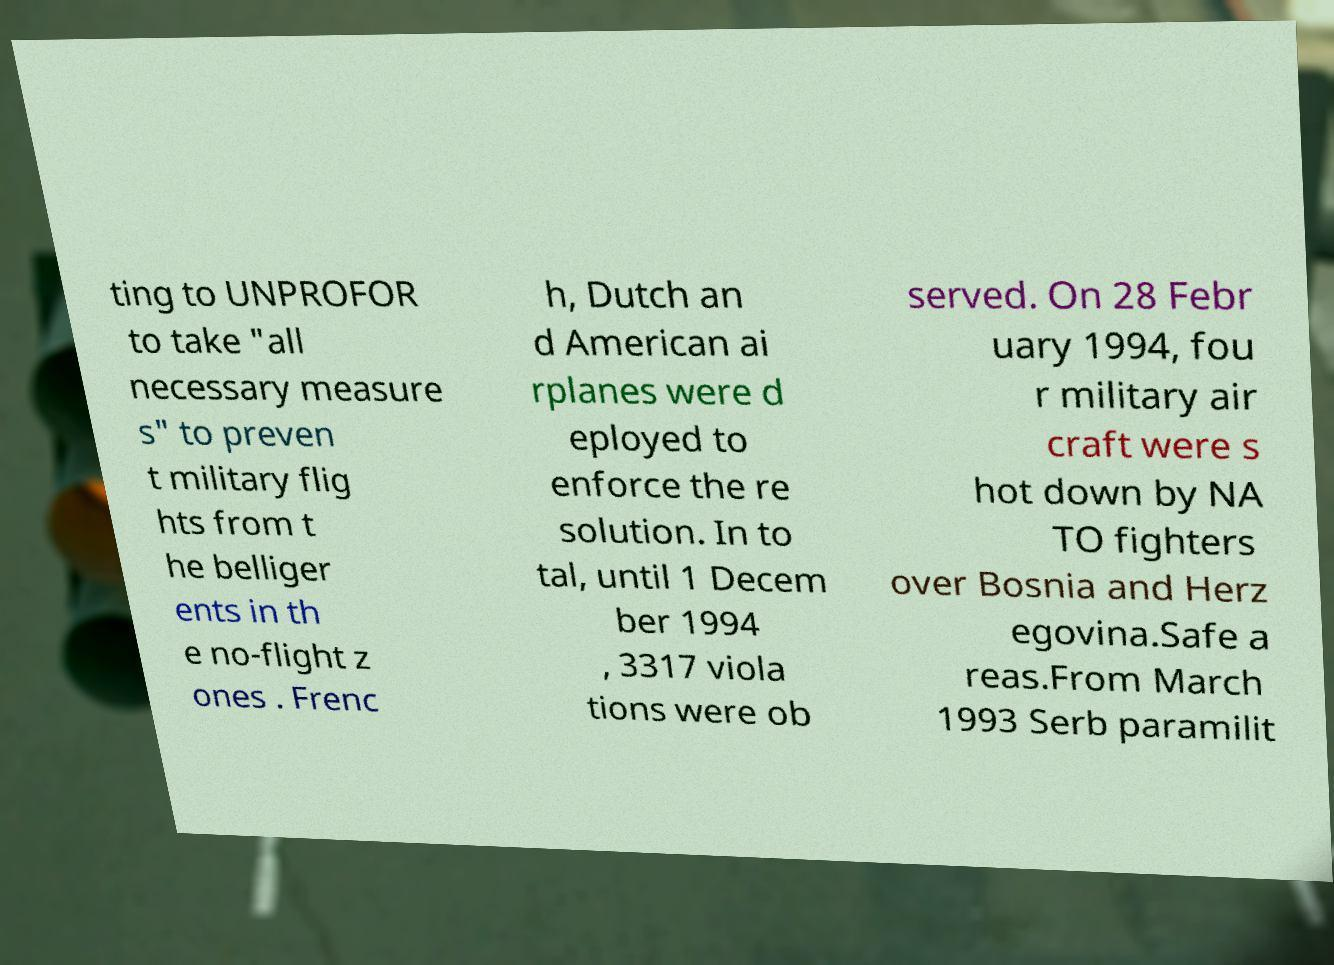Please identify and transcribe the text found in this image. ting to UNPROFOR to take "all necessary measure s" to preven t military flig hts from t he belliger ents in th e no-flight z ones . Frenc h, Dutch an d American ai rplanes were d eployed to enforce the re solution. In to tal, until 1 Decem ber 1994 , 3317 viola tions were ob served. On 28 Febr uary 1994, fou r military air craft were s hot down by NA TO fighters over Bosnia and Herz egovina.Safe a reas.From March 1993 Serb paramilit 